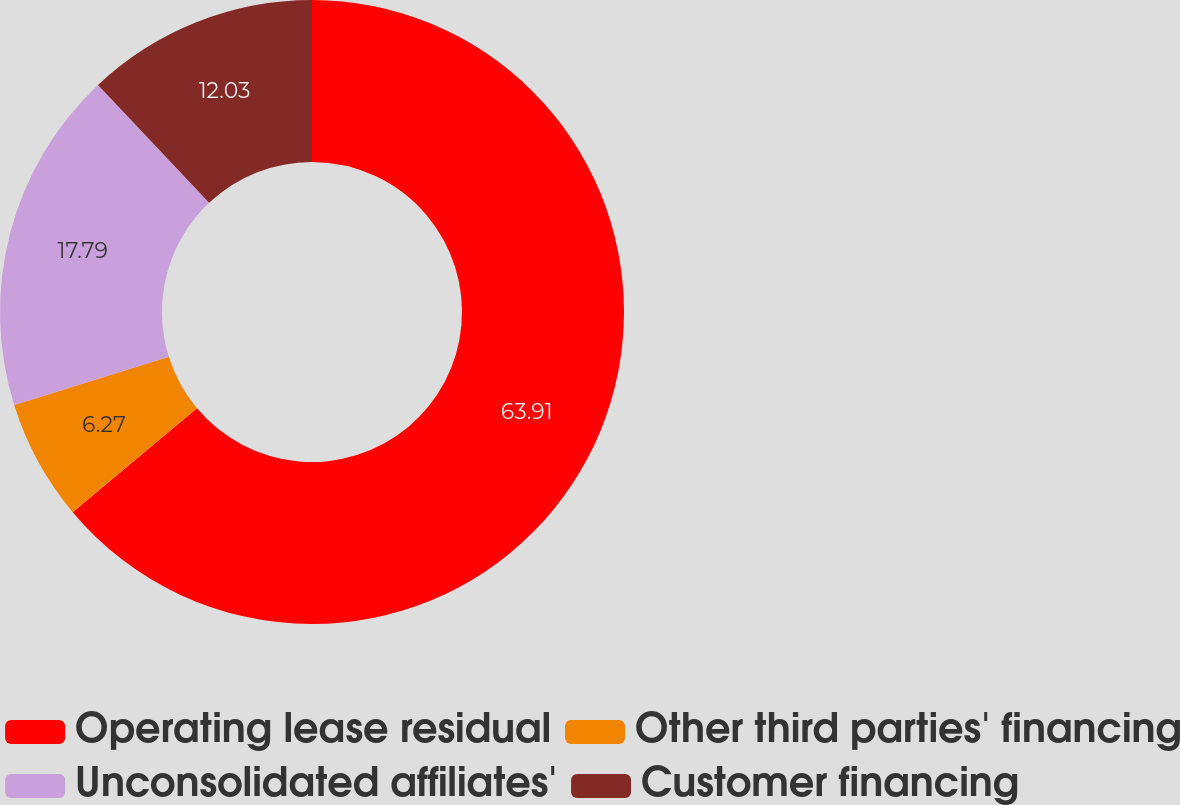Convert chart to OTSL. <chart><loc_0><loc_0><loc_500><loc_500><pie_chart><fcel>Operating lease residual<fcel>Other third parties' financing<fcel>Unconsolidated affiliates'<fcel>Customer financing<nl><fcel>63.91%<fcel>6.27%<fcel>17.79%<fcel>12.03%<nl></chart> 